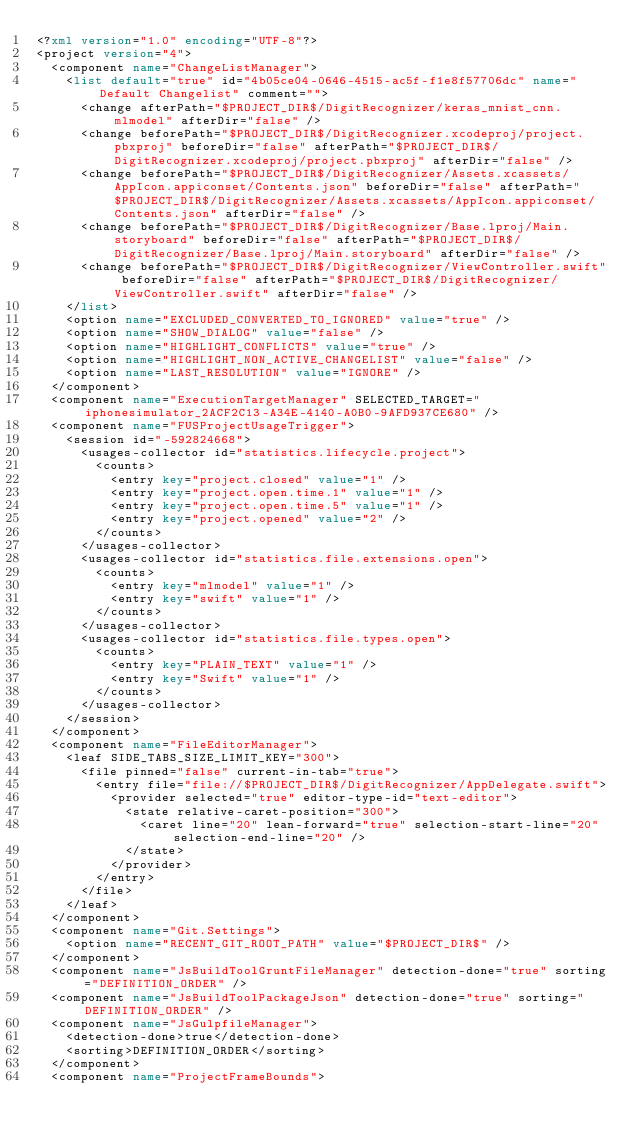<code> <loc_0><loc_0><loc_500><loc_500><_XML_><?xml version="1.0" encoding="UTF-8"?>
<project version="4">
  <component name="ChangeListManager">
    <list default="true" id="4b05ce04-0646-4515-ac5f-f1e8f57706dc" name="Default Changelist" comment="">
      <change afterPath="$PROJECT_DIR$/DigitRecognizer/keras_mnist_cnn.mlmodel" afterDir="false" />
      <change beforePath="$PROJECT_DIR$/DigitRecognizer.xcodeproj/project.pbxproj" beforeDir="false" afterPath="$PROJECT_DIR$/DigitRecognizer.xcodeproj/project.pbxproj" afterDir="false" />
      <change beforePath="$PROJECT_DIR$/DigitRecognizer/Assets.xcassets/AppIcon.appiconset/Contents.json" beforeDir="false" afterPath="$PROJECT_DIR$/DigitRecognizer/Assets.xcassets/AppIcon.appiconset/Contents.json" afterDir="false" />
      <change beforePath="$PROJECT_DIR$/DigitRecognizer/Base.lproj/Main.storyboard" beforeDir="false" afterPath="$PROJECT_DIR$/DigitRecognizer/Base.lproj/Main.storyboard" afterDir="false" />
      <change beforePath="$PROJECT_DIR$/DigitRecognizer/ViewController.swift" beforeDir="false" afterPath="$PROJECT_DIR$/DigitRecognizer/ViewController.swift" afterDir="false" />
    </list>
    <option name="EXCLUDED_CONVERTED_TO_IGNORED" value="true" />
    <option name="SHOW_DIALOG" value="false" />
    <option name="HIGHLIGHT_CONFLICTS" value="true" />
    <option name="HIGHLIGHT_NON_ACTIVE_CHANGELIST" value="false" />
    <option name="LAST_RESOLUTION" value="IGNORE" />
  </component>
  <component name="ExecutionTargetManager" SELECTED_TARGET="iphonesimulator_2ACF2C13-A34E-4140-A0B0-9AFD937CE680" />
  <component name="FUSProjectUsageTrigger">
    <session id="-592824668">
      <usages-collector id="statistics.lifecycle.project">
        <counts>
          <entry key="project.closed" value="1" />
          <entry key="project.open.time.1" value="1" />
          <entry key="project.open.time.5" value="1" />
          <entry key="project.opened" value="2" />
        </counts>
      </usages-collector>
      <usages-collector id="statistics.file.extensions.open">
        <counts>
          <entry key="mlmodel" value="1" />
          <entry key="swift" value="1" />
        </counts>
      </usages-collector>
      <usages-collector id="statistics.file.types.open">
        <counts>
          <entry key="PLAIN_TEXT" value="1" />
          <entry key="Swift" value="1" />
        </counts>
      </usages-collector>
    </session>
  </component>
  <component name="FileEditorManager">
    <leaf SIDE_TABS_SIZE_LIMIT_KEY="300">
      <file pinned="false" current-in-tab="true">
        <entry file="file://$PROJECT_DIR$/DigitRecognizer/AppDelegate.swift">
          <provider selected="true" editor-type-id="text-editor">
            <state relative-caret-position="300">
              <caret line="20" lean-forward="true" selection-start-line="20" selection-end-line="20" />
            </state>
          </provider>
        </entry>
      </file>
    </leaf>
  </component>
  <component name="Git.Settings">
    <option name="RECENT_GIT_ROOT_PATH" value="$PROJECT_DIR$" />
  </component>
  <component name="JsBuildToolGruntFileManager" detection-done="true" sorting="DEFINITION_ORDER" />
  <component name="JsBuildToolPackageJson" detection-done="true" sorting="DEFINITION_ORDER" />
  <component name="JsGulpfileManager">
    <detection-done>true</detection-done>
    <sorting>DEFINITION_ORDER</sorting>
  </component>
  <component name="ProjectFrameBounds"></code> 